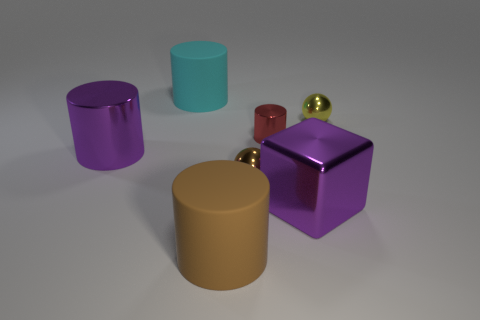Add 2 big purple shiny spheres. How many objects exist? 9 Subtract all cylinders. How many objects are left? 3 Add 6 big gray objects. How many big gray objects exist? 6 Subtract 1 yellow spheres. How many objects are left? 6 Subtract all blue metallic spheres. Subtract all blocks. How many objects are left? 6 Add 1 large metal blocks. How many large metal blocks are left? 2 